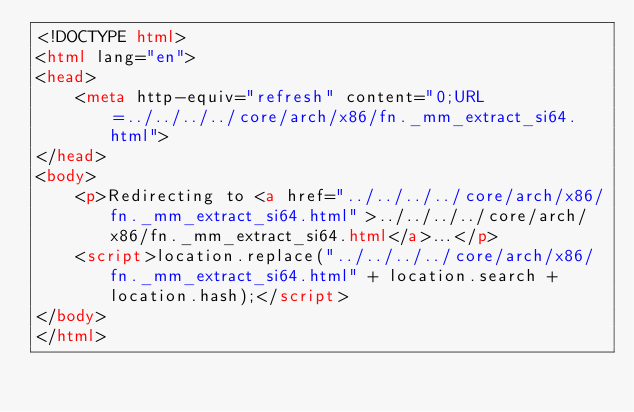<code> <loc_0><loc_0><loc_500><loc_500><_HTML_><!DOCTYPE html>
<html lang="en">
<head>
    <meta http-equiv="refresh" content="0;URL=../../../../core/arch/x86/fn._mm_extract_si64.html">
</head>
<body>
    <p>Redirecting to <a href="../../../../core/arch/x86/fn._mm_extract_si64.html">../../../../core/arch/x86/fn._mm_extract_si64.html</a>...</p>
    <script>location.replace("../../../../core/arch/x86/fn._mm_extract_si64.html" + location.search + location.hash);</script>
</body>
</html></code> 